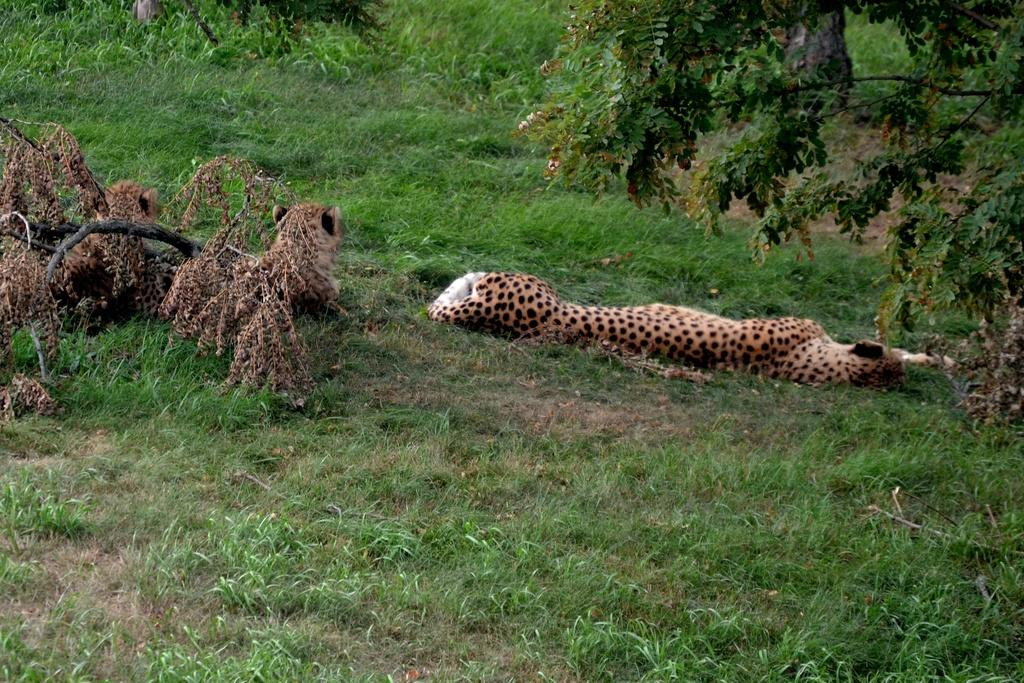What type of vegetation is in the foreground of the image? There is green grass in the foreground of the image. What can be seen in the middle of the image? There are dried leaves in the middle of the image. How many animals are present in the image? There are three animals that appear to be cheetahs in the image. What type of vegetation is visible at the top of the image? There is grass visible at the top of the image. Can you tell me how much salt is sprinkled on the grass in the image? There is no salt present in the image; it features green grass, dried leaves, and three animals that appear to be cheetahs. What type of deer can be seen in the image? There are no deer present in the image; it features three animals that appear to be cheetahs. 